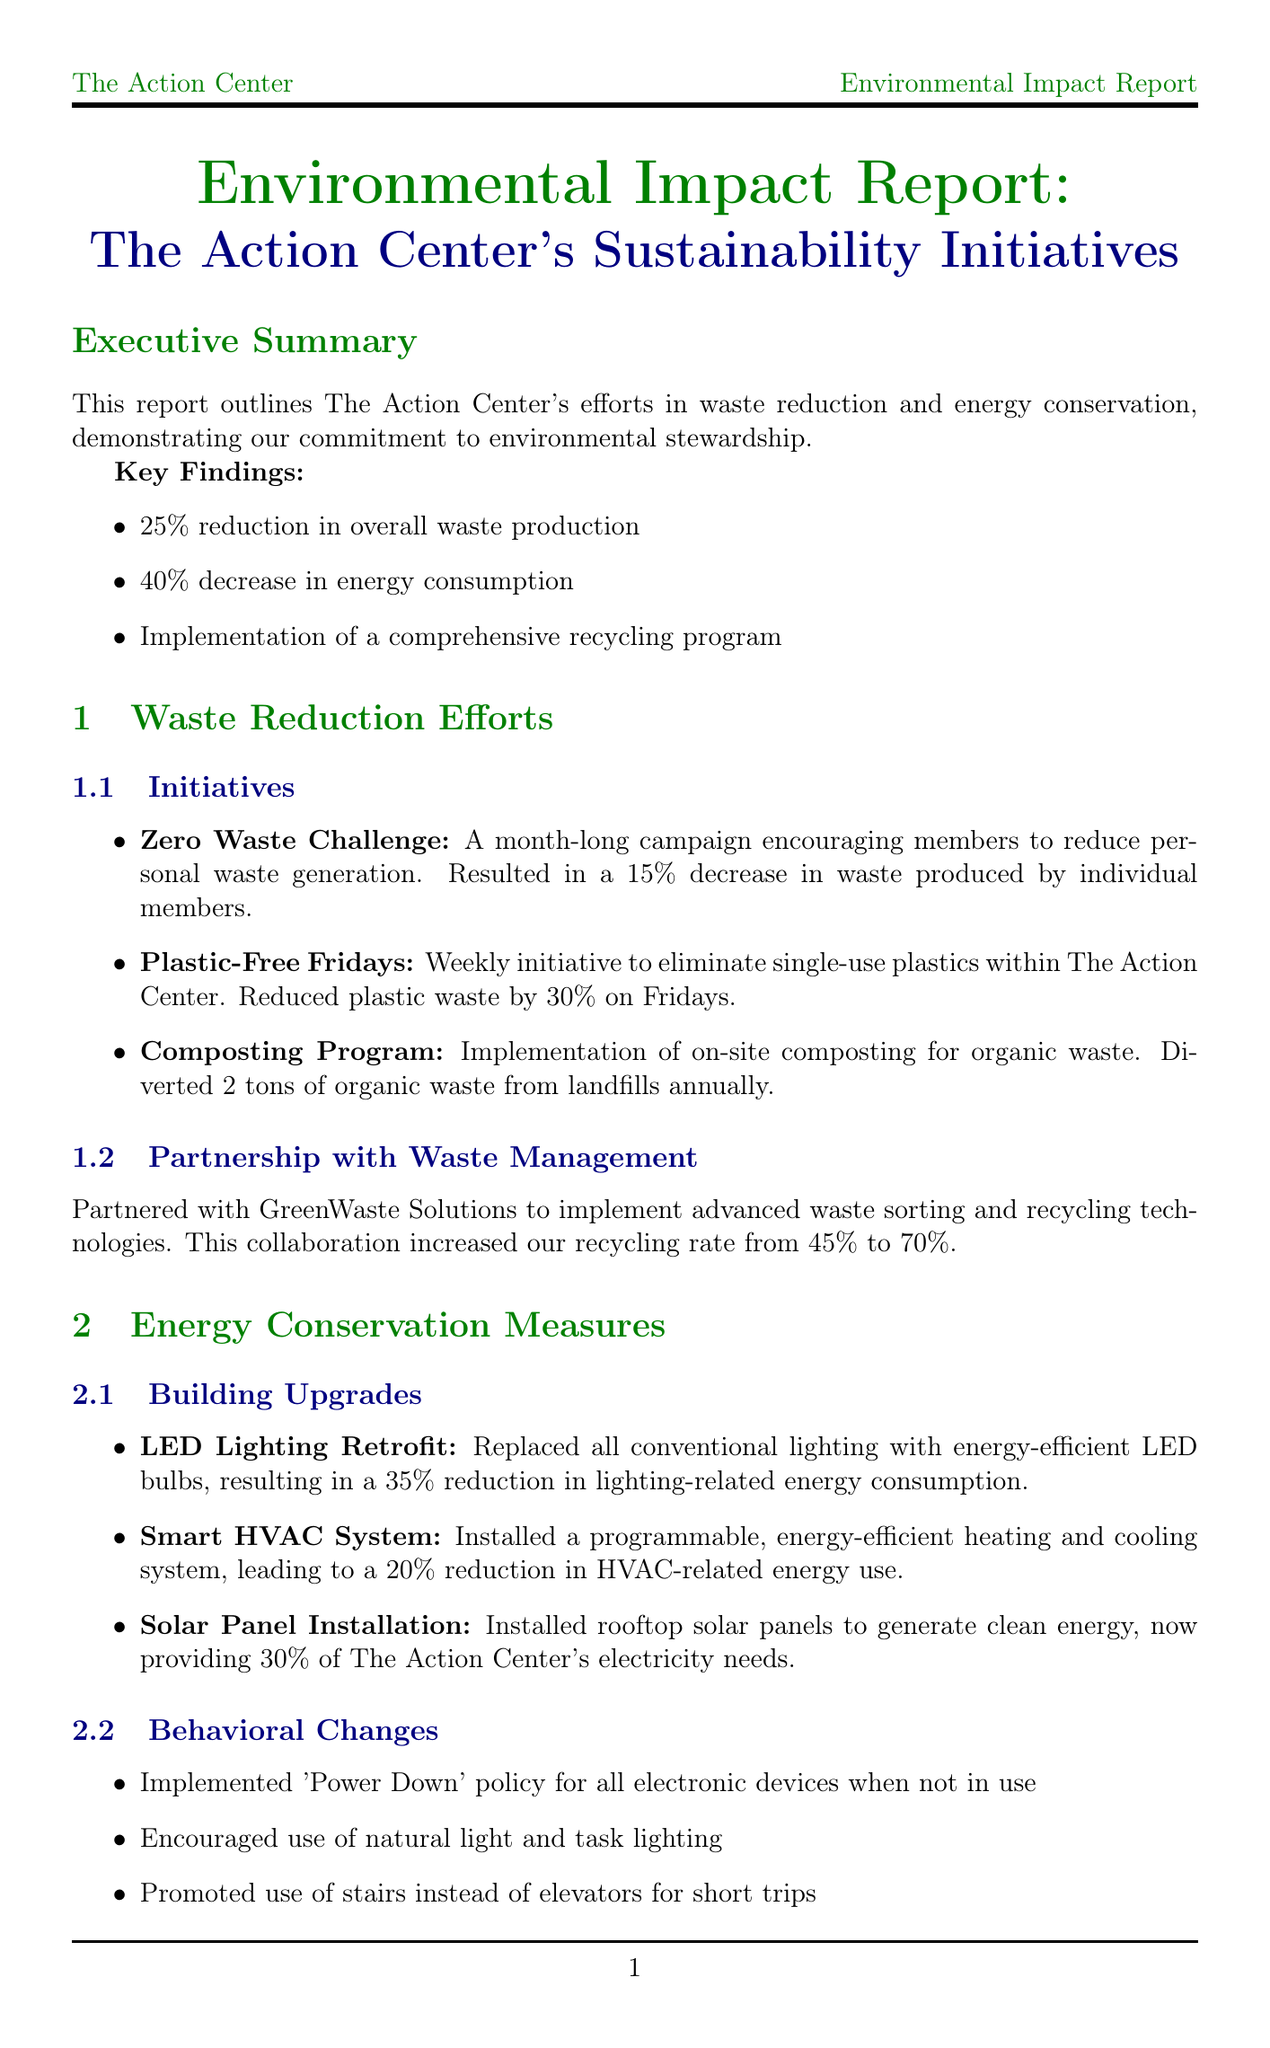what is the percentage reduction in overall waste production? The report states a "25% reduction in overall waste production."
Answer: 25% how much did energy consumption decrease? The document mentions a "40% decrease in energy consumption."
Answer: 40% what is the name of the partner for waste management? The partnership for waste management is with "GreenWaste Solutions."
Answer: GreenWaste Solutions how many tons of organic waste are diverted from landfills annually? The composting program "diverted 2 tons of organic waste from landfills annually."
Answer: 2 tons what is the average attendance for EcoAware Workshops? The average attendance is "50 members per session."
Answer: 50 members what is the energy savings from the LED lighting retrofit? The LED lighting retrofit resulted in a "35% reduction in lighting-related energy consumption."
Answer: 35% what is The Action Center's long-term vision for sustainability? The long-term vision stated is to "become a carbon-neutral organization by 2030."
Answer: carbon-neutral organization by 2030 how many new eco-friendly practices did the Green Team Initiative implement? The initiative "implemented 10 new eco-friendly practices in the past year."
Answer: 10 what impact did Plastic-Free Fridays have on plastic waste? The impact was a "30% reduction in plastic waste on Fridays."
Answer: 30% what is one of the short-term goals for waste reduction by 2024? One short-term goal is to "achieve 50% waste reduction by 2024."
Answer: 50% waste reduction by 2024 